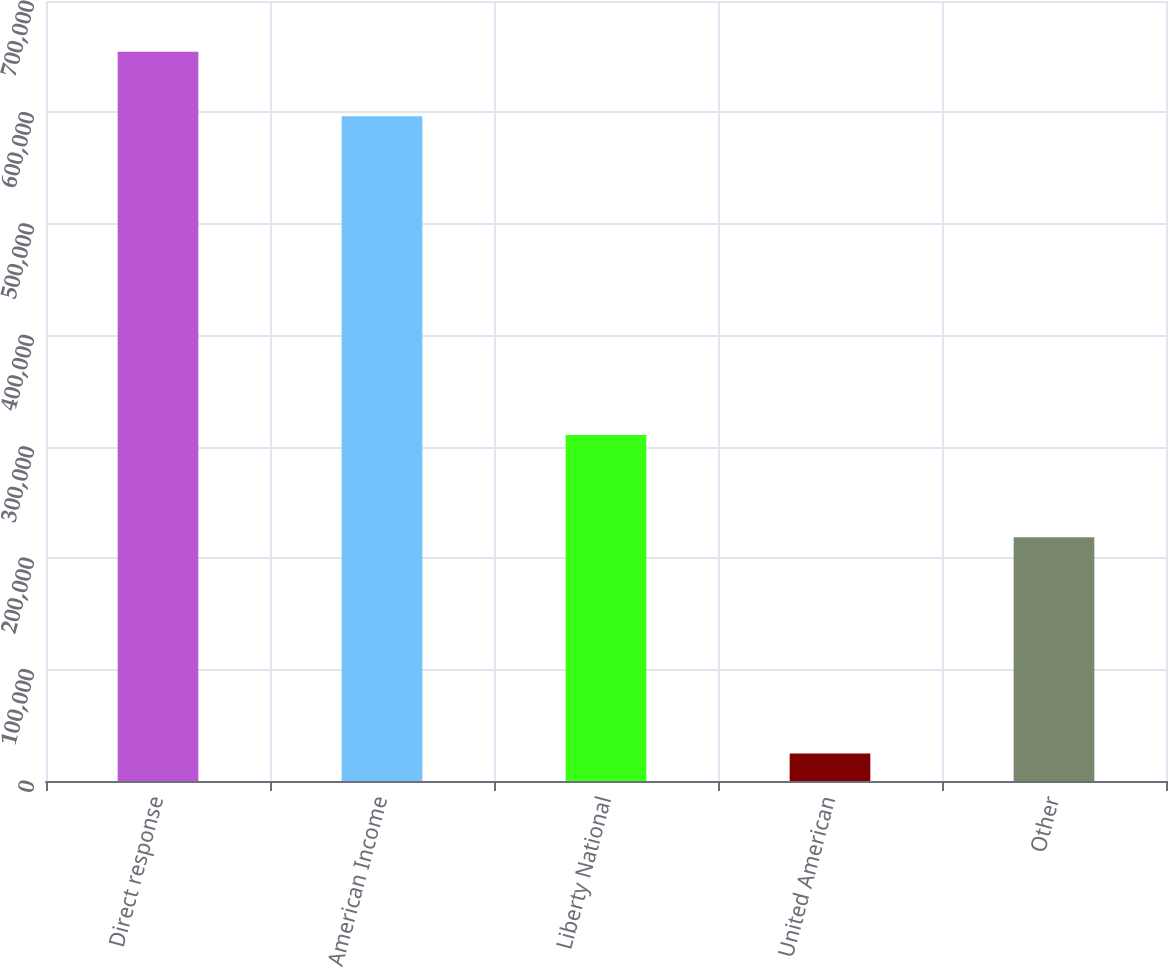Convert chart to OTSL. <chart><loc_0><loc_0><loc_500><loc_500><bar_chart><fcel>Direct response<fcel>American Income<fcel>Liberty National<fcel>United American<fcel>Other<nl><fcel>654370<fcel>596583<fcel>310475<fcel>24726<fcel>218669<nl></chart> 